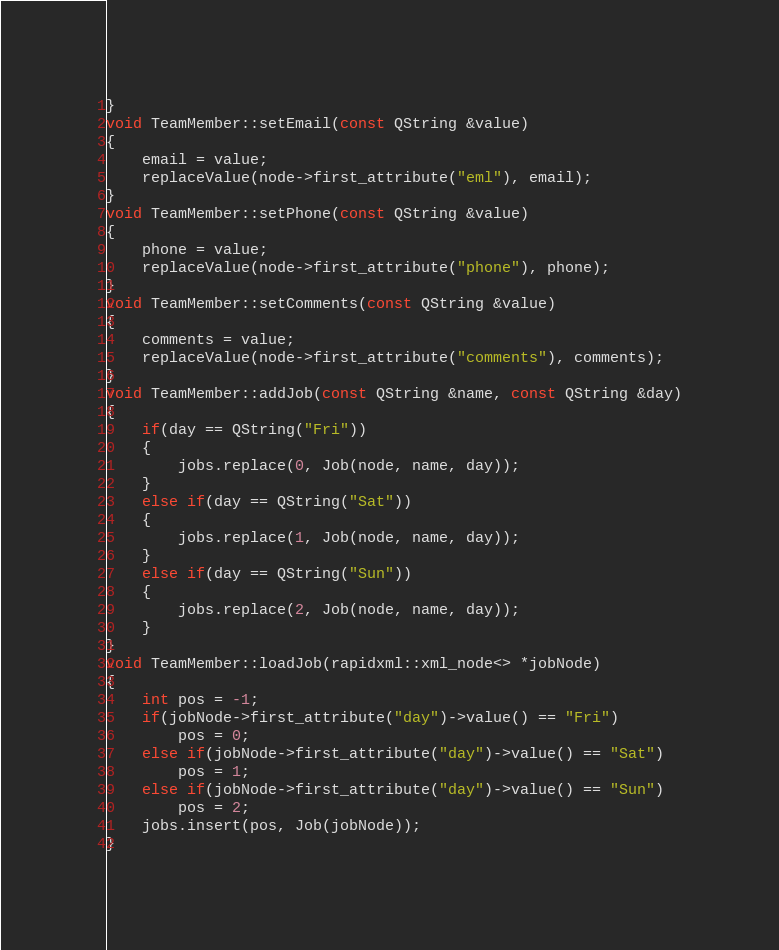Convert code to text. <code><loc_0><loc_0><loc_500><loc_500><_C++_>}
void TeamMember::setEmail(const QString &value)
{
    email = value;
    replaceValue(node->first_attribute("eml"), email);
}
void TeamMember::setPhone(const QString &value)
{
    phone = value;
    replaceValue(node->first_attribute("phone"), phone);
}
void TeamMember::setComments(const QString &value)
{
    comments = value;
    replaceValue(node->first_attribute("comments"), comments);
}
void TeamMember::addJob(const QString &name, const QString &day)
{
    if(day == QString("Fri"))
    {
        jobs.replace(0, Job(node, name, day));
    }
    else if(day == QString("Sat"))
    {
        jobs.replace(1, Job(node, name, day));
    }
    else if(day == QString("Sun"))
    {
        jobs.replace(2, Job(node, name, day));
    }
}
void TeamMember::loadJob(rapidxml::xml_node<> *jobNode)
{
    int pos = -1;
    if(jobNode->first_attribute("day")->value() == "Fri")
        pos = 0;
    else if(jobNode->first_attribute("day")->value() == "Sat")
        pos = 1;
    else if(jobNode->first_attribute("day")->value() == "Sun")
        pos = 2;
    jobs.insert(pos, Job(jobNode));
}
</code> 